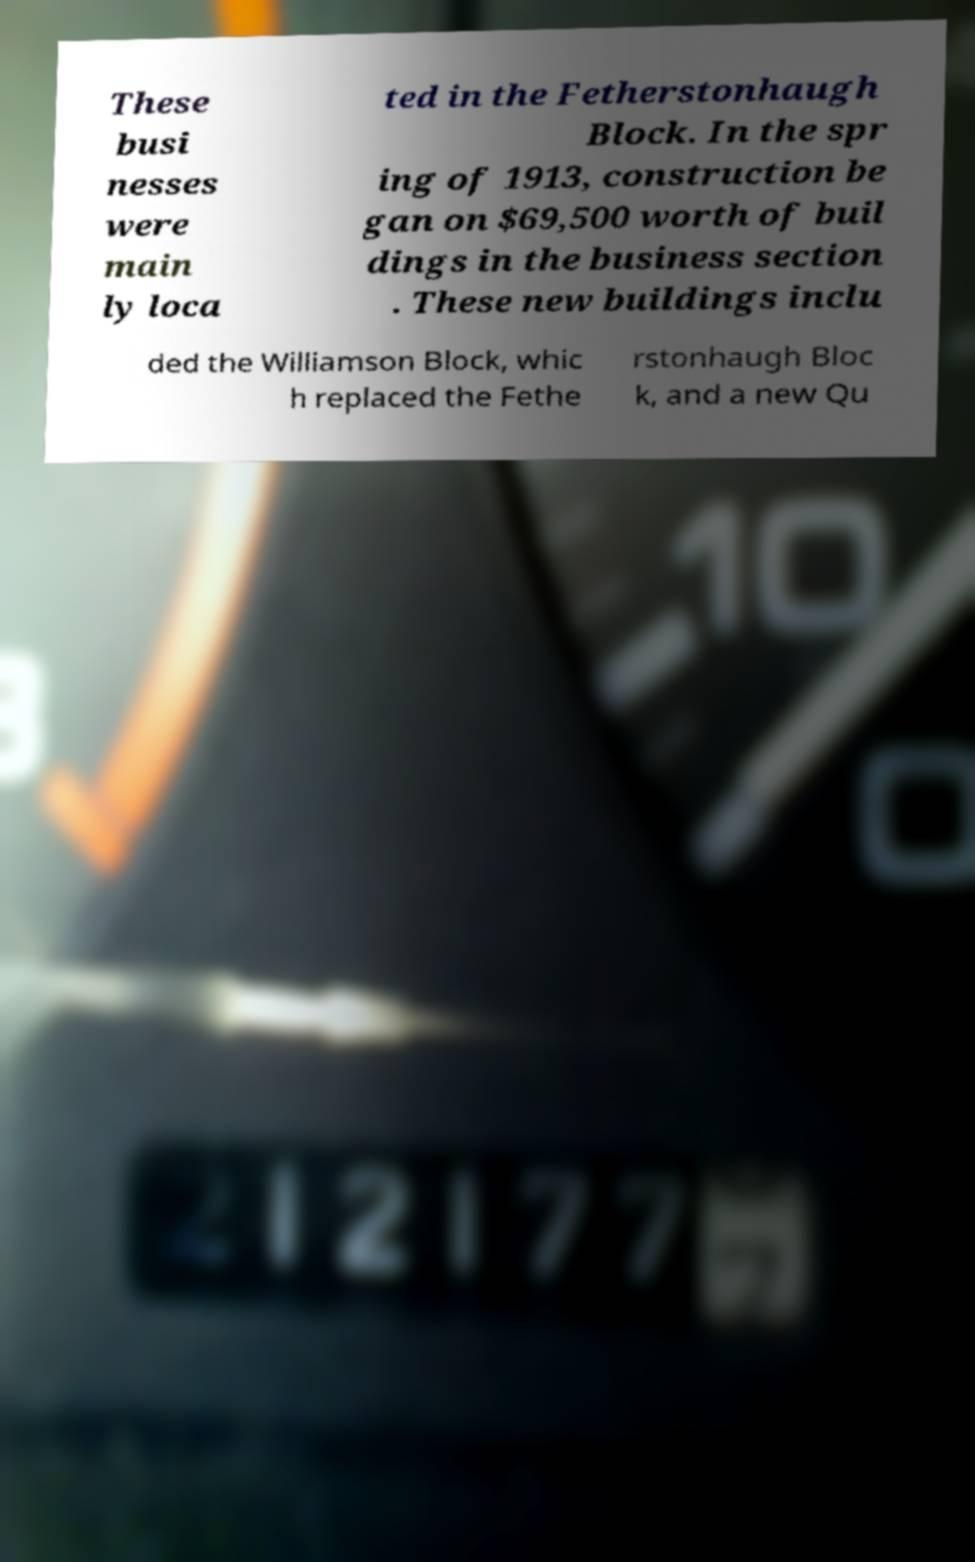There's text embedded in this image that I need extracted. Can you transcribe it verbatim? These busi nesses were main ly loca ted in the Fetherstonhaugh Block. In the spr ing of 1913, construction be gan on $69,500 worth of buil dings in the business section . These new buildings inclu ded the Williamson Block, whic h replaced the Fethe rstonhaugh Bloc k, and a new Qu 